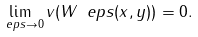Convert formula to latex. <formula><loc_0><loc_0><loc_500><loc_500>\lim _ { \ e p s \to 0 } v ( W _ { \ } e p s ( x , y ) ) = 0 .</formula> 